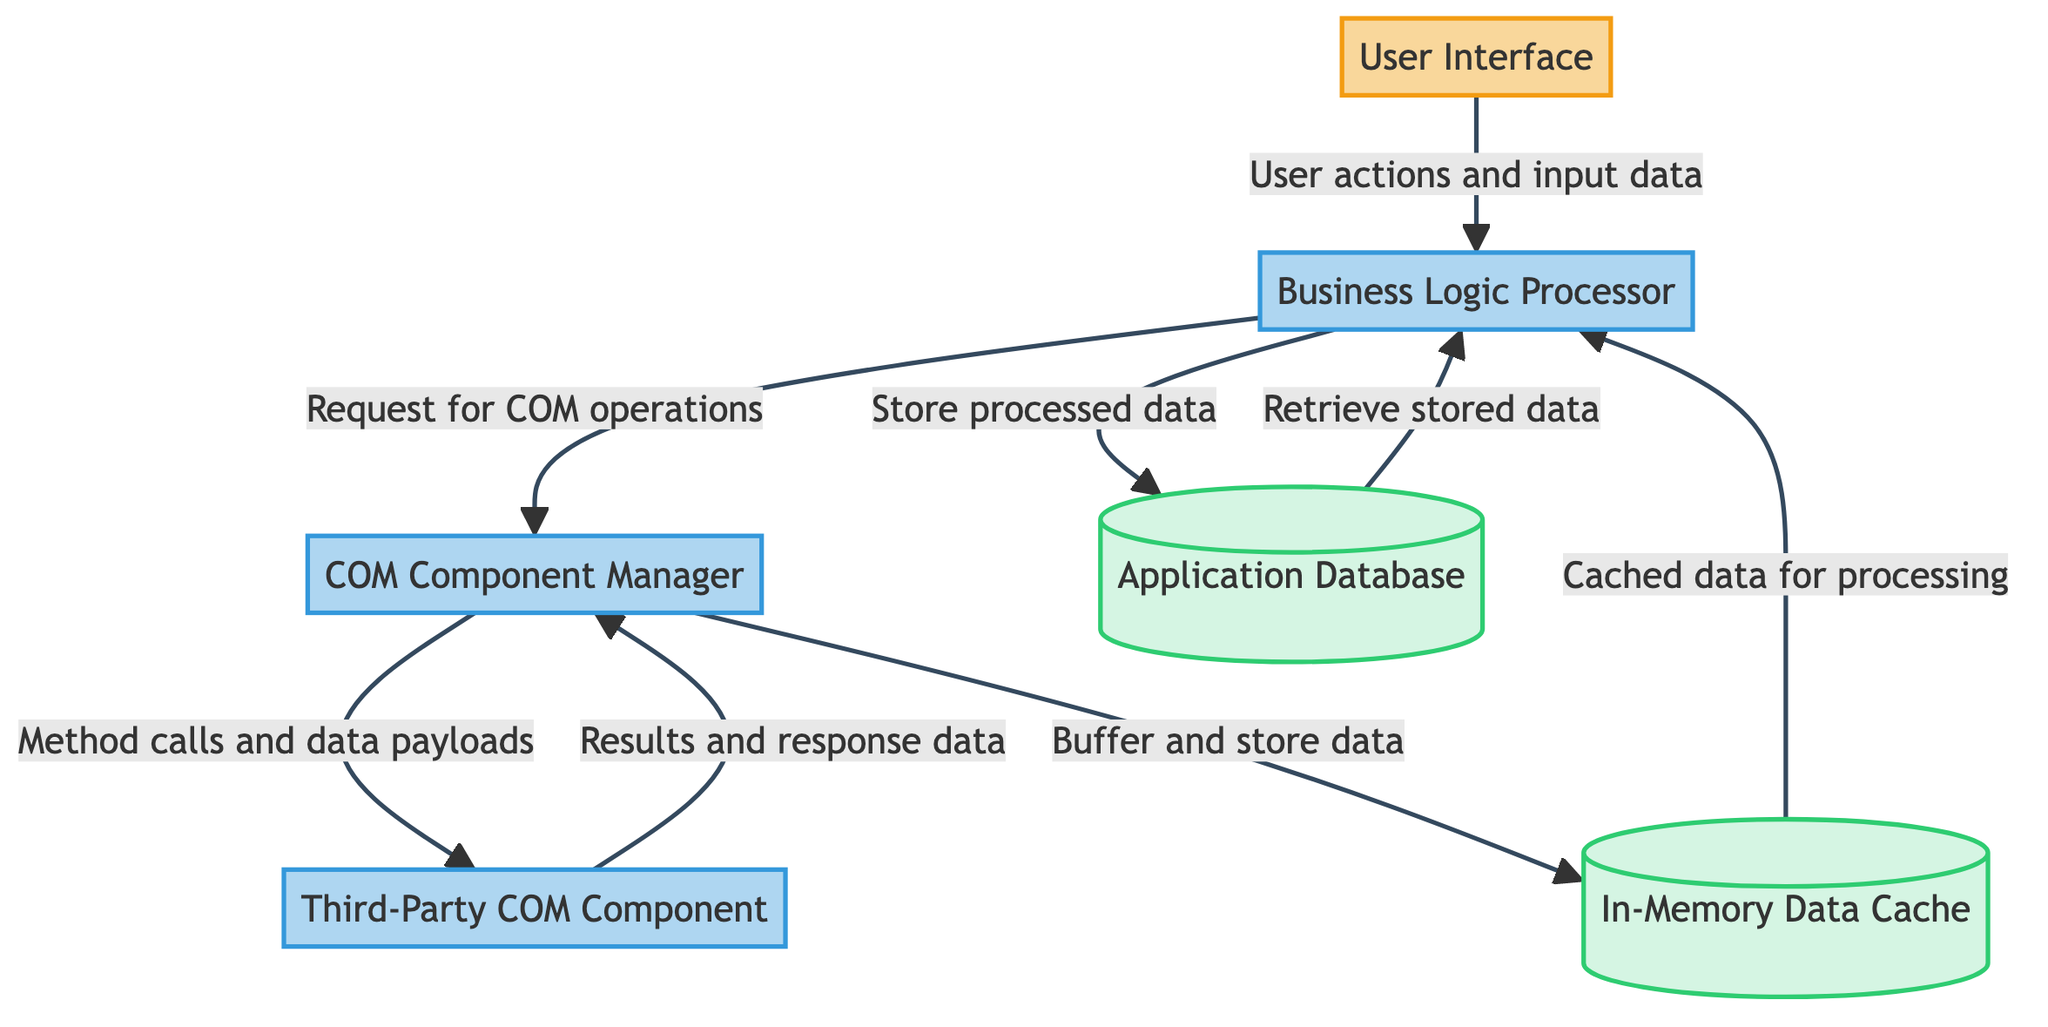What is the name of the external entity in the diagram? The diagram includes the external entity labeled "User Interface."
Answer: User Interface How many processes are depicted in the diagram? There are four processes shown in the diagram: COM Component Manager, Business Logic Processor, Third-Party COM Component, and User Interface.
Answer: Four What data flow originates from the Business Logic Processor? The Business Logic Processor sends requests to the COM Component Manager to perform operations via third-party COM components.
Answer: Request for COM operations Which data store receives data from the COM Component Manager? The In-Memory Data Cache receives buffered data from the COM Component Manager.
Answer: In-Memory Data Cache What does the Third-Party COM Component return to the COM Component Manager? The Third-Party COM Component returns results and response data back to the COM Component Manager.
Answer: Results and response data Explain the interaction between the Business Logic Processor and the Application Database. The Business Logic Processor stores processed data into the Application Database and later retrieves stored data for ongoing operations, establishing a back-and-forth interaction.
Answer: Back-and-forth interaction What kind of data does the In-Memory Data Cache provide to the Business Logic Processor? The In-Memory Data Cache provides cached data for processing and decisions back to the Business Logic Processor.
Answer: Cached data for processing Which component initiates user interactions according to the diagram? The User Interface is the component where users initiate their interactions with the application, sending input to the Business Logic Processor.
Answer: User Interface How does the COM Component Manager utilize the In-Memory Data Cache? The COM Component Manager buffers and temporarily stores data in the In-Memory Data Cache during inter-process communication.
Answer: Buffers and temporarily stores data 